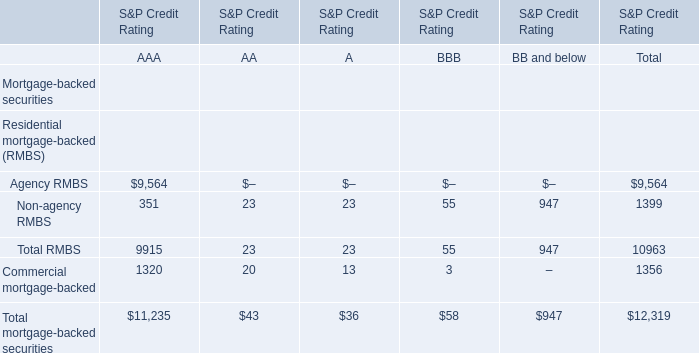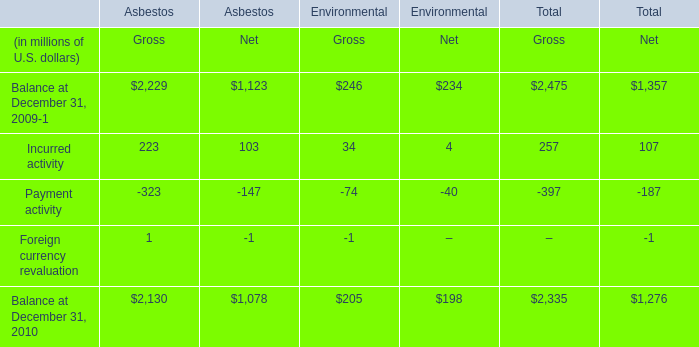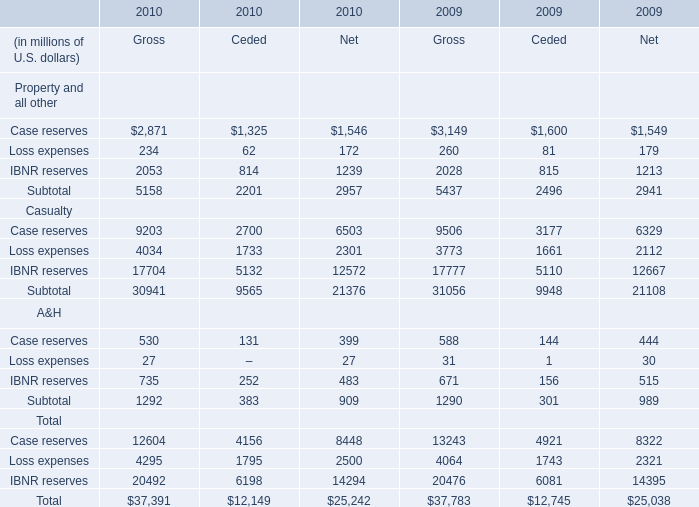what is the percent change in the fair value financial market instruments as part of the hedging strategy during 2010 compare to 2009? 
Computations: ((21 - 47) / 47)
Answer: -0.55319. 